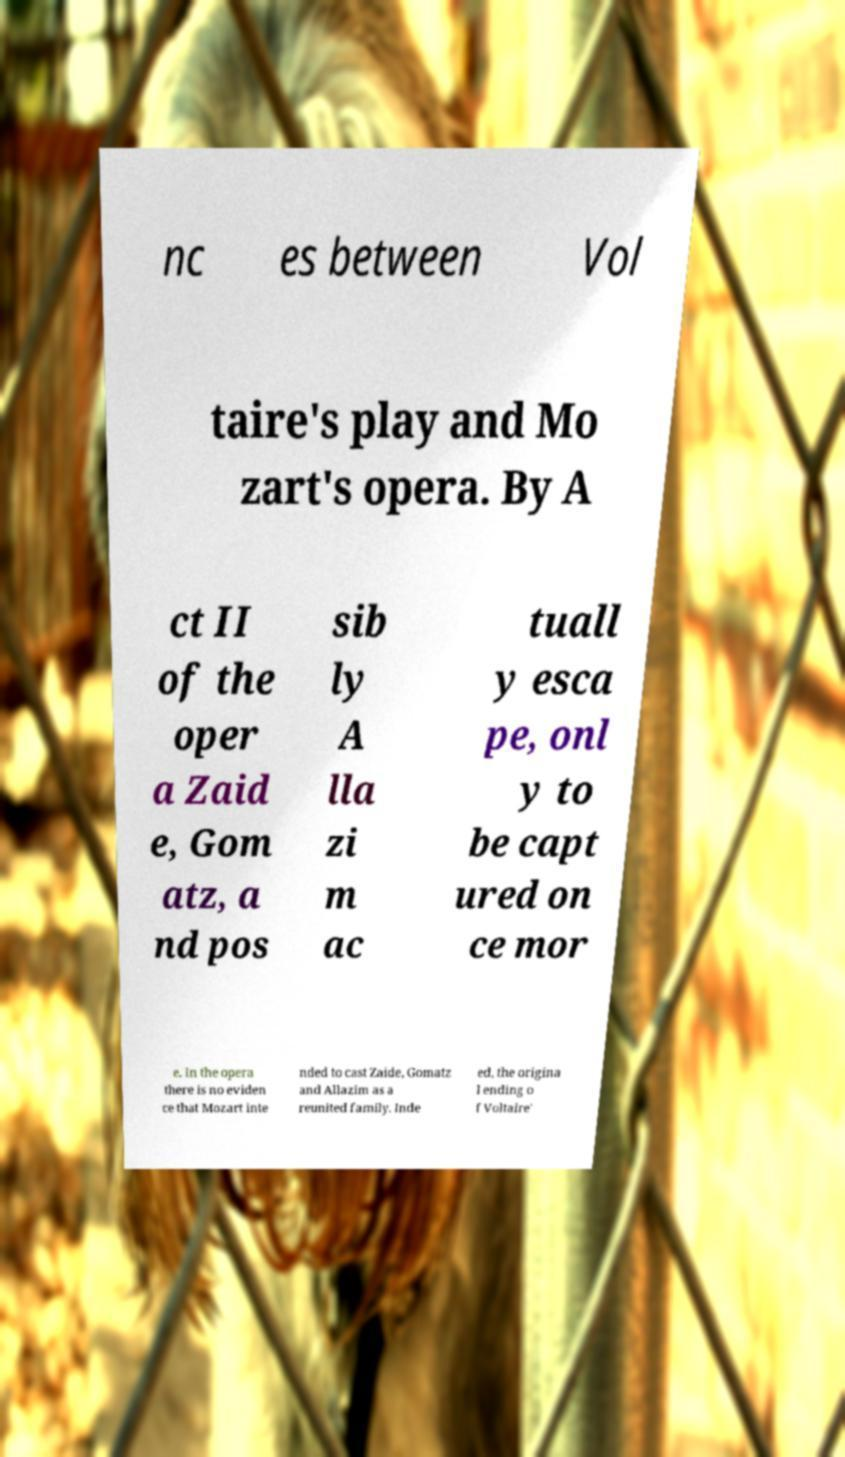There's text embedded in this image that I need extracted. Can you transcribe it verbatim? nc es between Vol taire's play and Mo zart's opera. By A ct II of the oper a Zaid e, Gom atz, a nd pos sib ly A lla zi m ac tuall y esca pe, onl y to be capt ured on ce mor e. In the opera there is no eviden ce that Mozart inte nded to cast Zaide, Gomatz and Allazim as a reunited family. Inde ed, the origina l ending o f Voltaire' 